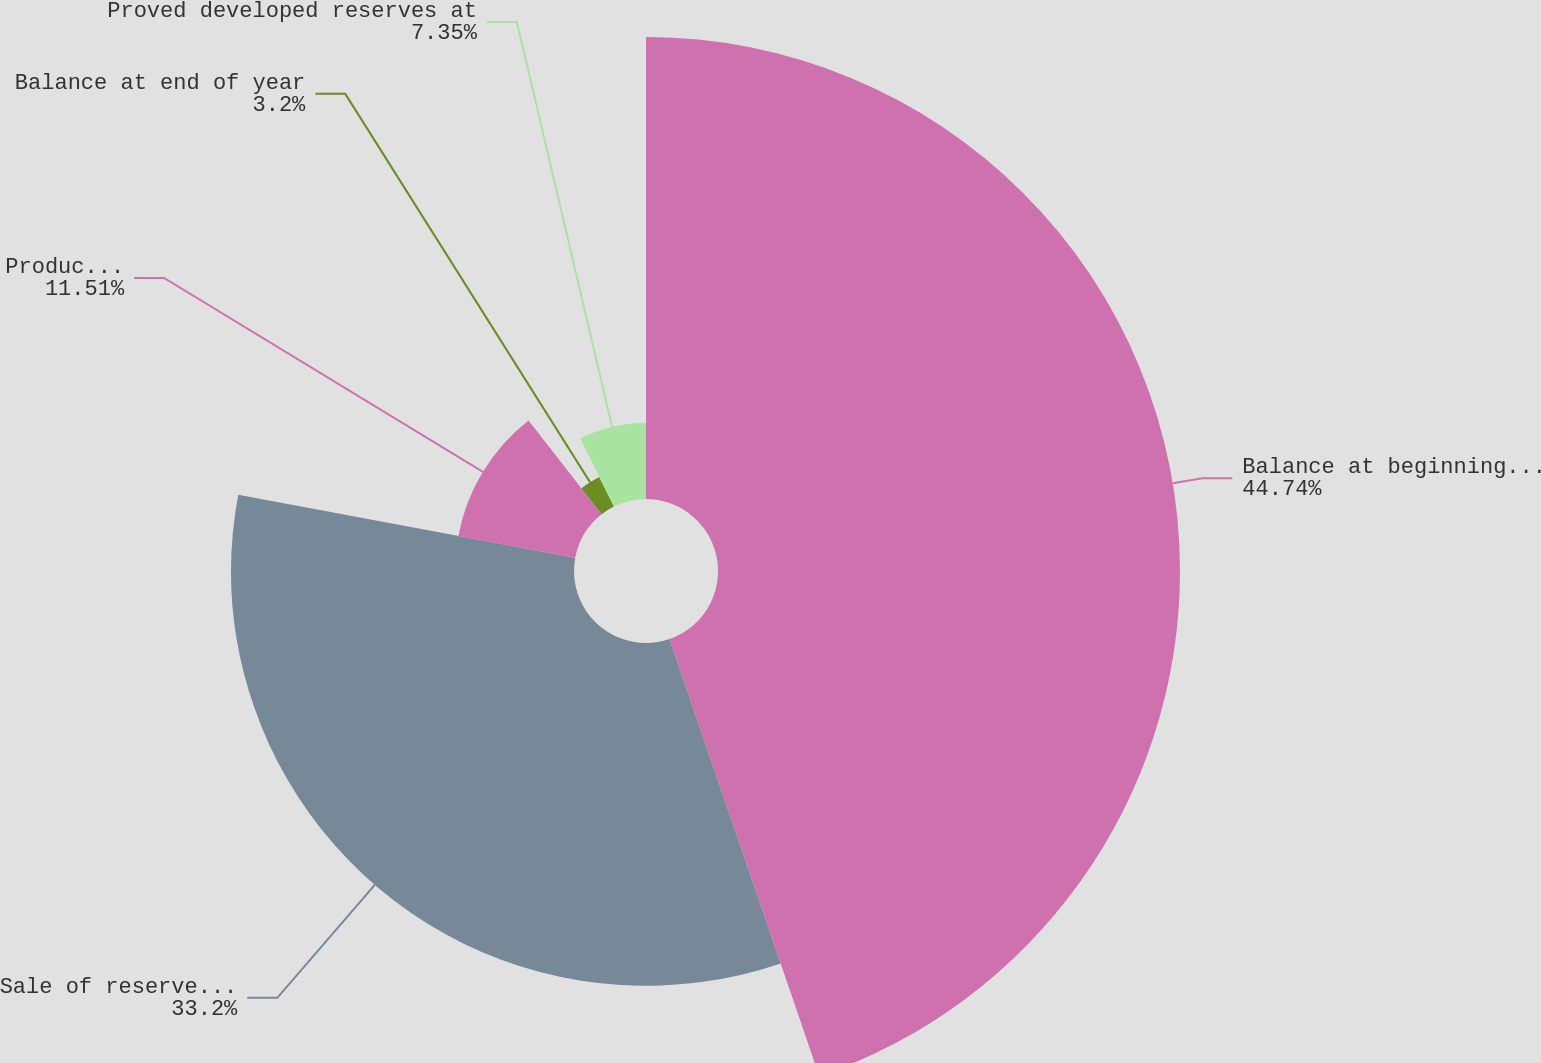Convert chart to OTSL. <chart><loc_0><loc_0><loc_500><loc_500><pie_chart><fcel>Balance at beginning of year<fcel>Sale of reserves in-place<fcel>Production<fcel>Balance at end of year<fcel>Proved developed reserves at<nl><fcel>44.74%<fcel>33.2%<fcel>11.51%<fcel>3.2%<fcel>7.35%<nl></chart> 